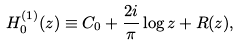<formula> <loc_0><loc_0><loc_500><loc_500>H ^ { ( 1 ) } _ { 0 } ( z ) \equiv C _ { 0 } + \frac { 2 i } { \pi } \log z + R ( z ) ,</formula> 